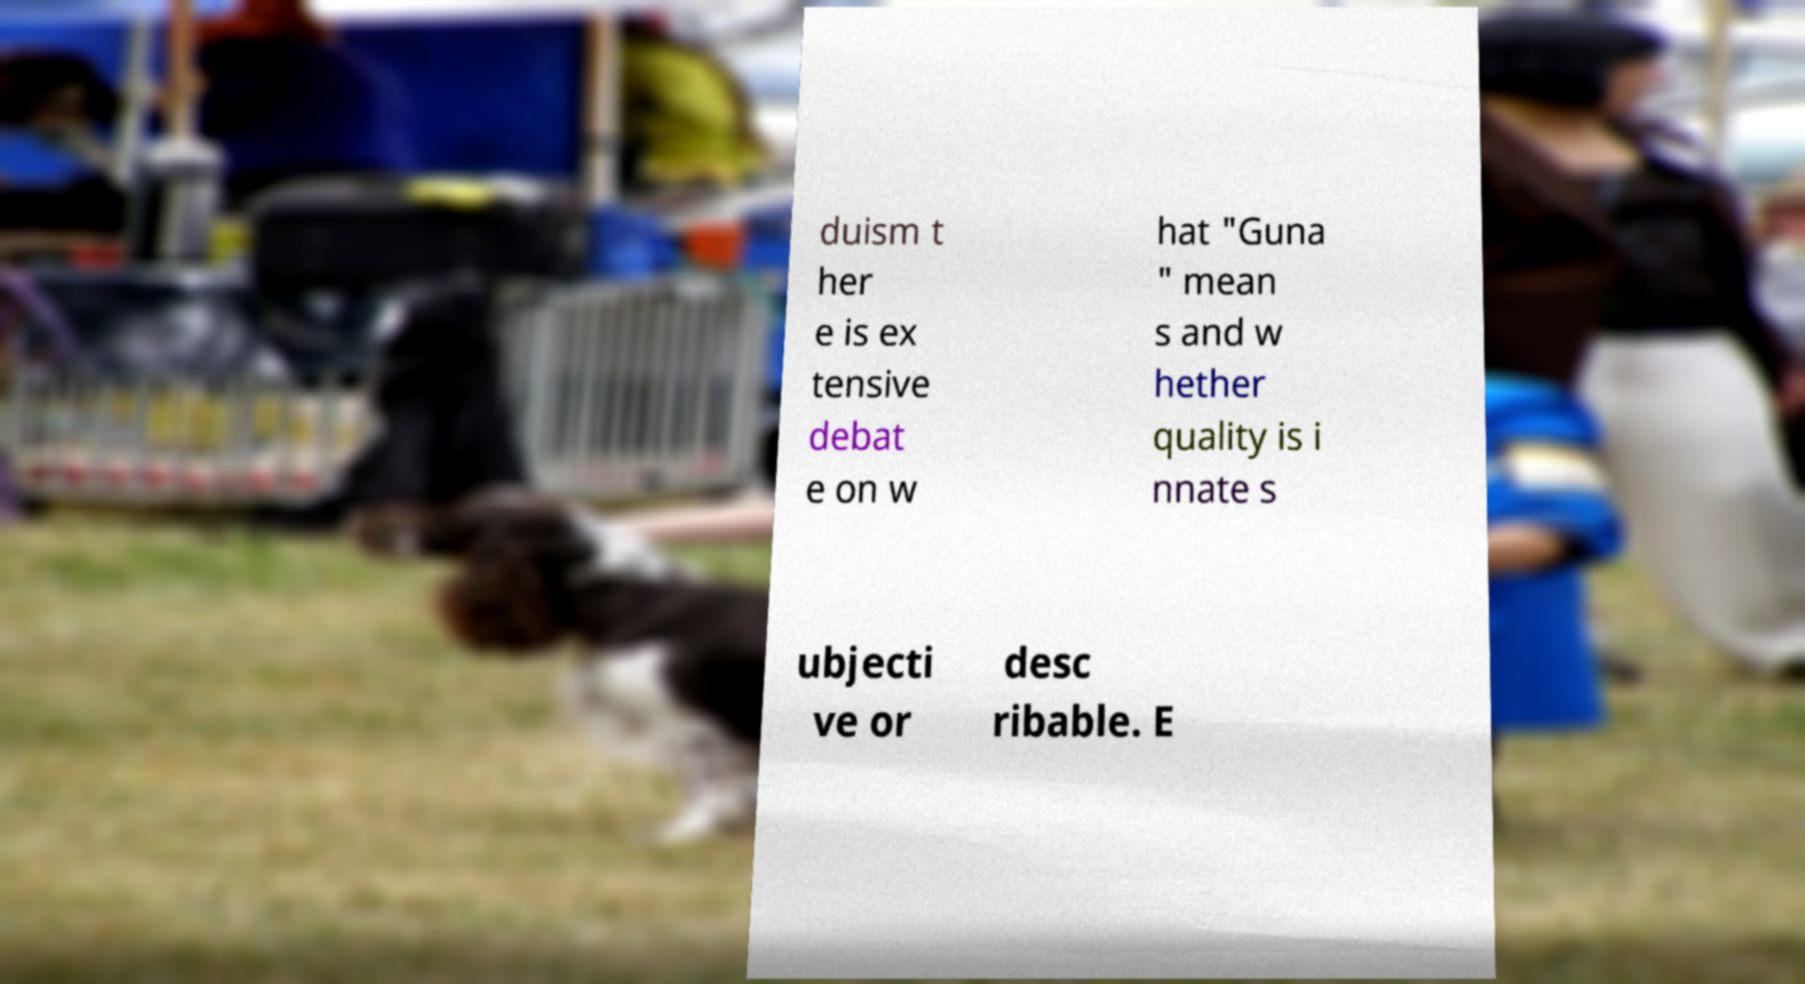I need the written content from this picture converted into text. Can you do that? duism t her e is ex tensive debat e on w hat "Guna " mean s and w hether quality is i nnate s ubjecti ve or desc ribable. E 